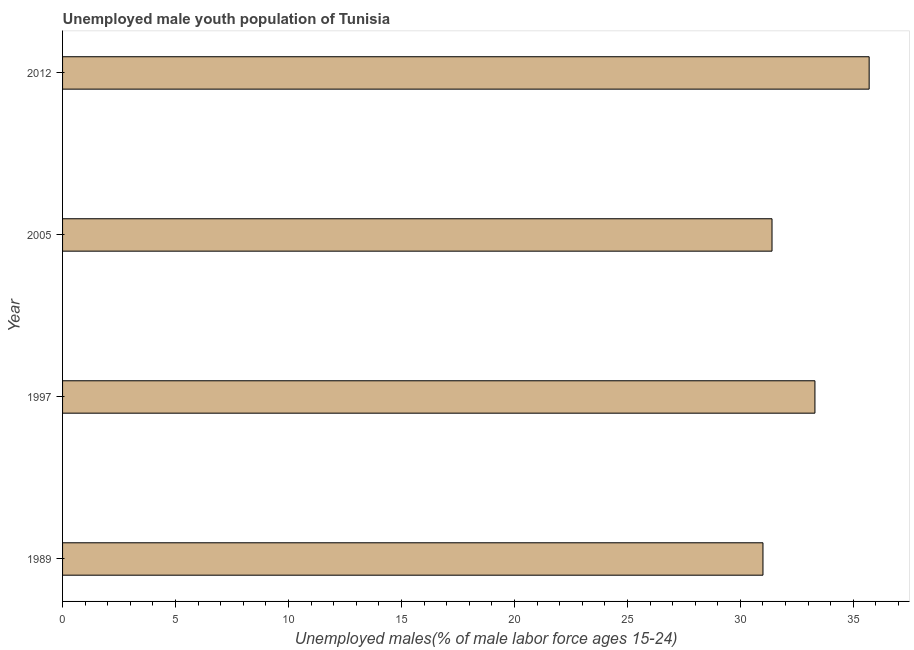Does the graph contain grids?
Keep it short and to the point. No. What is the title of the graph?
Ensure brevity in your answer.  Unemployed male youth population of Tunisia. What is the label or title of the X-axis?
Offer a very short reply. Unemployed males(% of male labor force ages 15-24). What is the unemployed male youth in 2005?
Make the answer very short. 31.4. Across all years, what is the maximum unemployed male youth?
Your answer should be compact. 35.7. What is the sum of the unemployed male youth?
Keep it short and to the point. 131.4. What is the difference between the unemployed male youth in 1989 and 2005?
Offer a terse response. -0.4. What is the average unemployed male youth per year?
Give a very brief answer. 32.85. What is the median unemployed male youth?
Give a very brief answer. 32.35. In how many years, is the unemployed male youth greater than 24 %?
Ensure brevity in your answer.  4. Do a majority of the years between 1997 and 1989 (inclusive) have unemployed male youth greater than 29 %?
Make the answer very short. No. Is the unemployed male youth in 1989 less than that in 2005?
Offer a terse response. Yes. Is the difference between the unemployed male youth in 2005 and 2012 greater than the difference between any two years?
Your response must be concise. No. What is the difference between the highest and the second highest unemployed male youth?
Keep it short and to the point. 2.4. Is the sum of the unemployed male youth in 1989 and 1997 greater than the maximum unemployed male youth across all years?
Ensure brevity in your answer.  Yes. What is the difference between the highest and the lowest unemployed male youth?
Your answer should be very brief. 4.7. In how many years, is the unemployed male youth greater than the average unemployed male youth taken over all years?
Provide a short and direct response. 2. How many bars are there?
Your response must be concise. 4. How many years are there in the graph?
Your response must be concise. 4. What is the difference between two consecutive major ticks on the X-axis?
Provide a short and direct response. 5. Are the values on the major ticks of X-axis written in scientific E-notation?
Provide a succinct answer. No. What is the Unemployed males(% of male labor force ages 15-24) in 1997?
Offer a terse response. 33.3. What is the Unemployed males(% of male labor force ages 15-24) of 2005?
Offer a very short reply. 31.4. What is the Unemployed males(% of male labor force ages 15-24) of 2012?
Ensure brevity in your answer.  35.7. What is the difference between the Unemployed males(% of male labor force ages 15-24) in 1989 and 2012?
Your answer should be compact. -4.7. What is the difference between the Unemployed males(% of male labor force ages 15-24) in 1997 and 2005?
Give a very brief answer. 1.9. What is the difference between the Unemployed males(% of male labor force ages 15-24) in 1997 and 2012?
Provide a short and direct response. -2.4. What is the ratio of the Unemployed males(% of male labor force ages 15-24) in 1989 to that in 1997?
Your answer should be compact. 0.93. What is the ratio of the Unemployed males(% of male labor force ages 15-24) in 1989 to that in 2005?
Provide a succinct answer. 0.99. What is the ratio of the Unemployed males(% of male labor force ages 15-24) in 1989 to that in 2012?
Ensure brevity in your answer.  0.87. What is the ratio of the Unemployed males(% of male labor force ages 15-24) in 1997 to that in 2005?
Offer a very short reply. 1.06. What is the ratio of the Unemployed males(% of male labor force ages 15-24) in 1997 to that in 2012?
Provide a short and direct response. 0.93. What is the ratio of the Unemployed males(% of male labor force ages 15-24) in 2005 to that in 2012?
Make the answer very short. 0.88. 